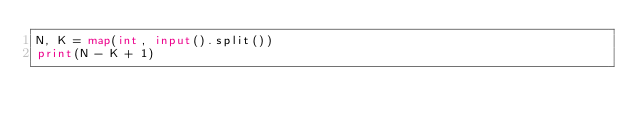Convert code to text. <code><loc_0><loc_0><loc_500><loc_500><_Python_>N, K = map(int, input().split())
print(N - K + 1)

</code> 